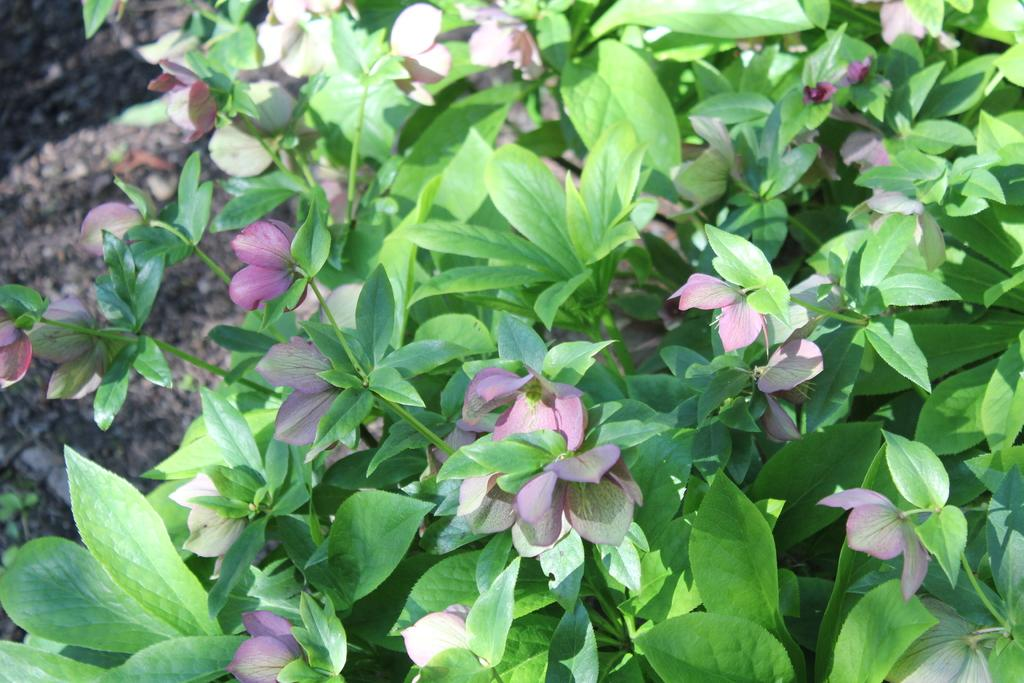What is present in the image? There is a plant in the image. What can be observed about the leaves of the plant? The plant has green leaves and violet color leaves. Is the plant sinking in quicksand in the image? No, there is no quicksand present in the image, and the plant is not sinking. Can you see a banana hanging from the plant in the image? No, there is no banana present in the image. 